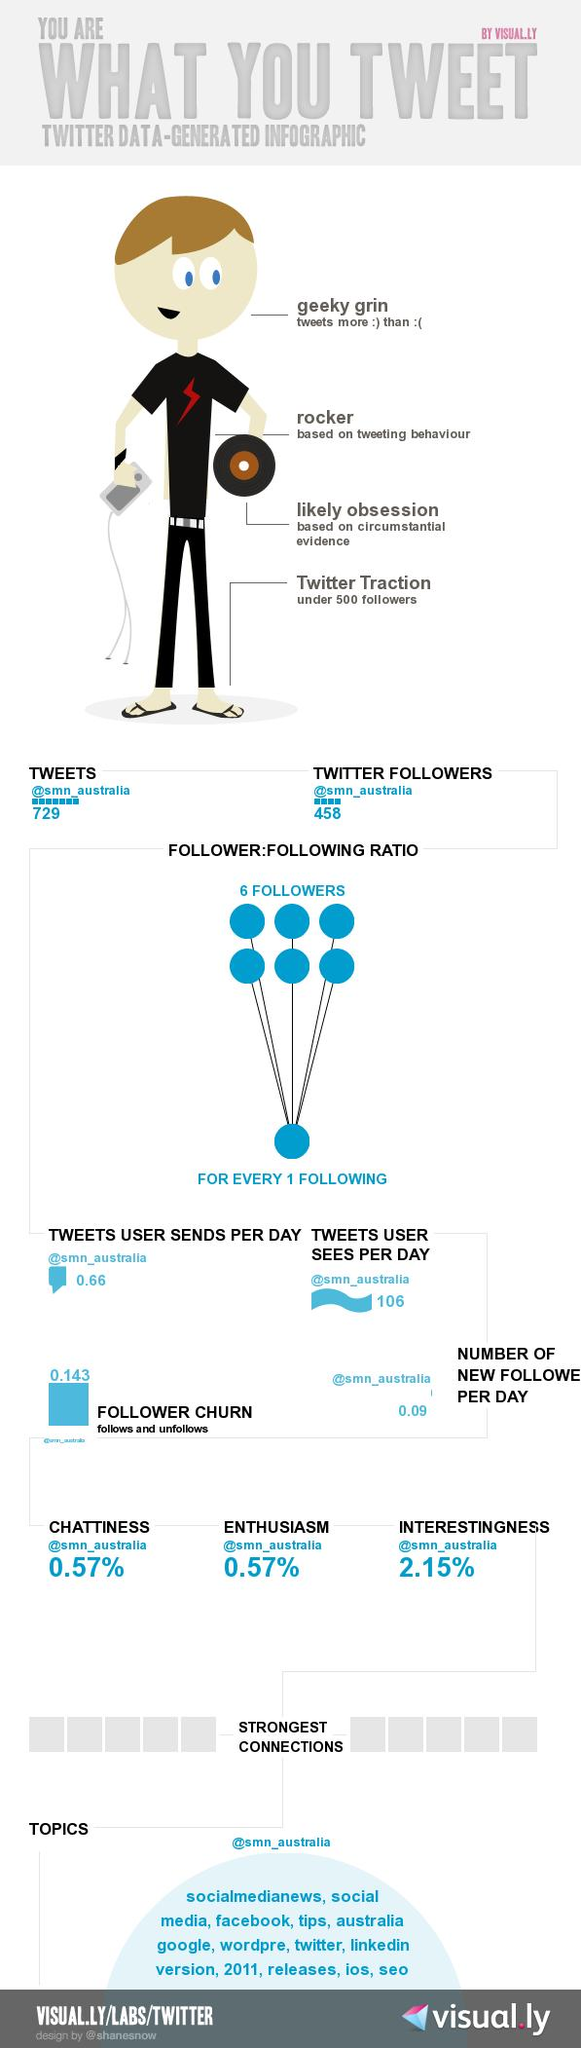Point out several critical features in this image. The percentage of interestingness is 2.15 and... As of now, @smn\_australia has 458 Twitter followers. On average, users see approximately 106 tweets per day. 